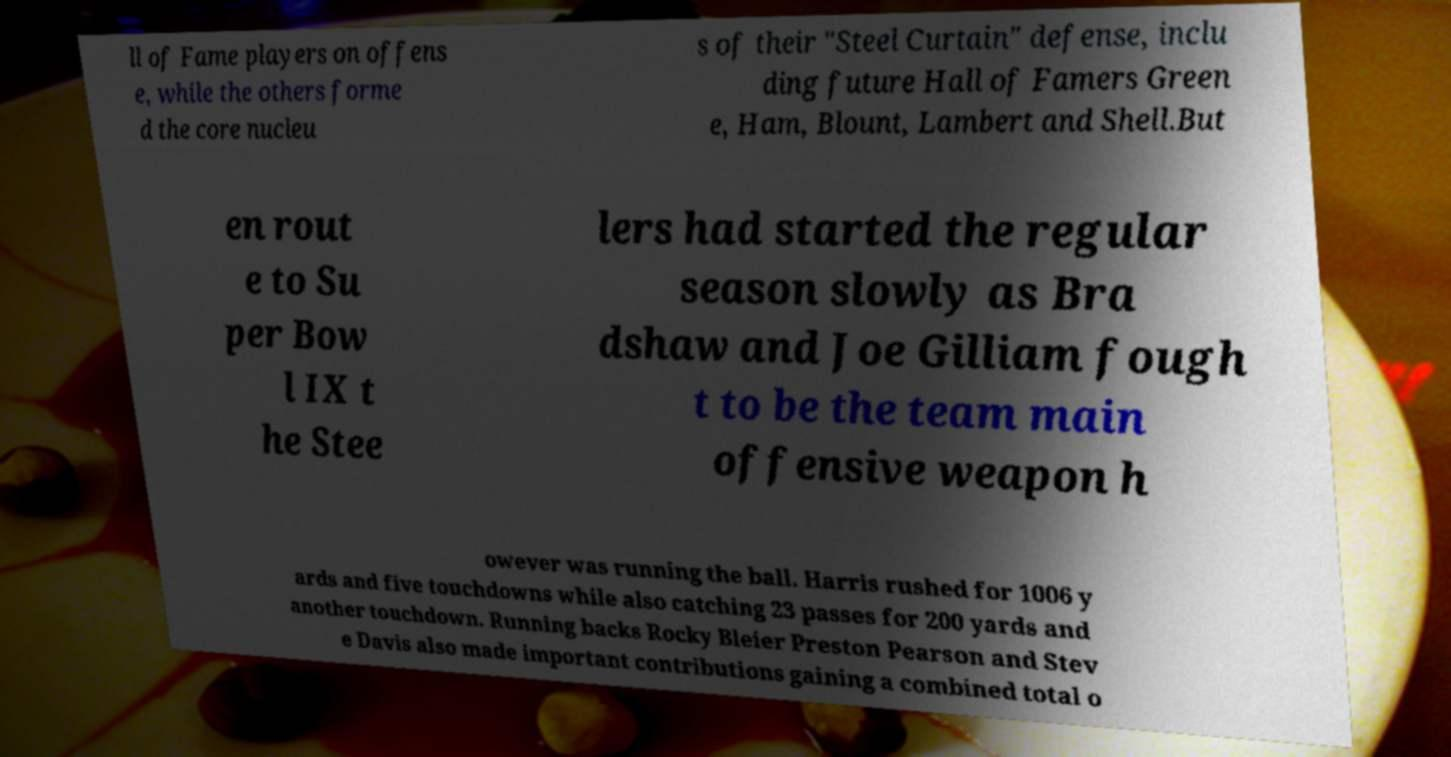There's text embedded in this image that I need extracted. Can you transcribe it verbatim? ll of Fame players on offens e, while the others forme d the core nucleu s of their "Steel Curtain" defense, inclu ding future Hall of Famers Green e, Ham, Blount, Lambert and Shell.But en rout e to Su per Bow l IX t he Stee lers had started the regular season slowly as Bra dshaw and Joe Gilliam fough t to be the team main offensive weapon h owever was running the ball. Harris rushed for 1006 y ards and five touchdowns while also catching 23 passes for 200 yards and another touchdown. Running backs Rocky Bleier Preston Pearson and Stev e Davis also made important contributions gaining a combined total o 